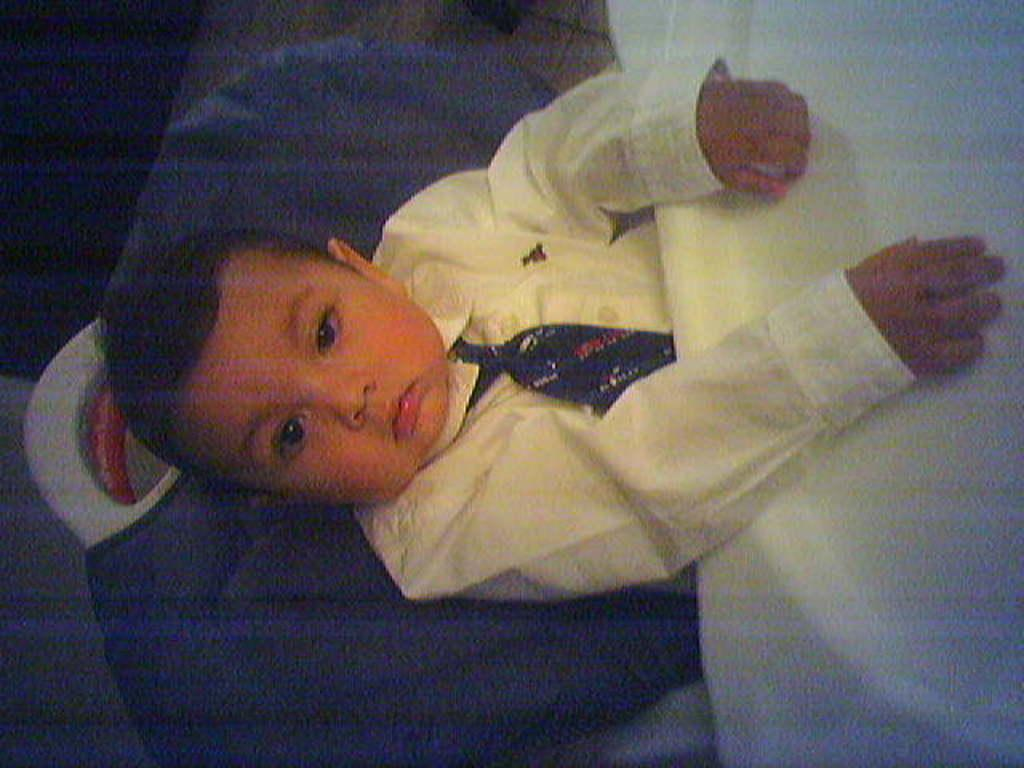What is the main subject of the image? The main subject of the image is a boy. What is the boy wearing in the image? The boy is wearing a shirt in the image. What is the boy doing in the image? The boy is sitting on a chair in the image. Reasoning: Let' Let's think step by step in order to produce the conversation. We start by identifying the main subject of the image, which is the boy. Then, we describe what the boy is wearing, which is a shirt. Finally, we observe the boy's actions, noting that he is sitting on a chair. Each question is designed to elicit a specific detail about the image that is known from the provided facts. Absurd Question/Answer: What type of poison is the boy holding in the image? There is no poison present in the image; the boy is simply sitting on a chair wearing a shirt. 